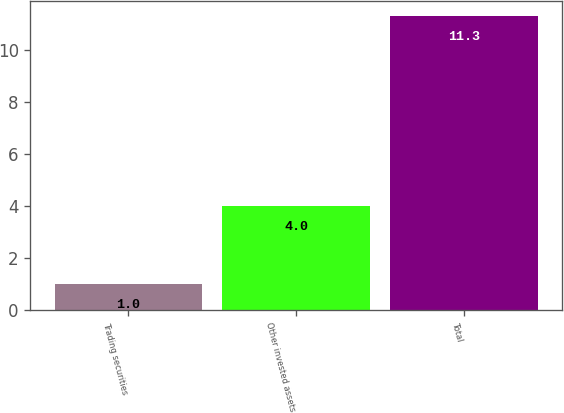<chart> <loc_0><loc_0><loc_500><loc_500><bar_chart><fcel>Trading securities<fcel>Other invested assets<fcel>Total<nl><fcel>1<fcel>4<fcel>11.3<nl></chart> 